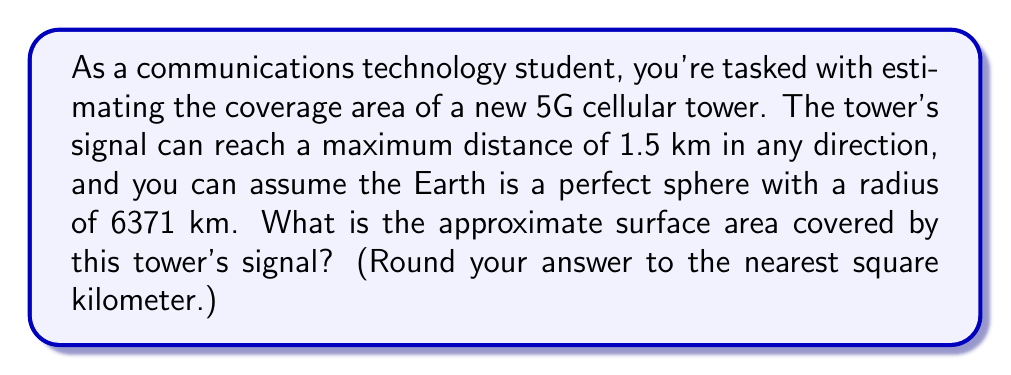Could you help me with this problem? To solve this problem, we'll use concepts from spherical geometry. Let's break it down step-by-step:

1) The coverage area of the cellular tower forms a spherical cap on the Earth's surface.

2) The radius of this spherical cap (r) is the maximum signal distance: 1.5 km.

3) We need to find the height (h) of this spherical cap:
   $$h = R - \sqrt{R^2 - r^2}$$
   where R is the Earth's radius (6371 km) and r is the signal radius (1.5 km).

4) Calculating h:
   $$h = 6371 - \sqrt{6371^2 - 1.5^2} \approx 0.000176 \text{ km}$$

5) The formula for the surface area of a spherical cap is:
   $$A = 2\pi Rh$$

6) Substituting our values:
   $$A = 2\pi(6371)(0.000176) \approx 7.0685 \text{ km}^2$$

7) Rounding to the nearest square kilometer:
   $$A \approx 7 \text{ km}^2$$

[asy]
import geometry;

size(200);
pair O = (0,0);
real R = 100;
real r = 23.5;
real h = R - sqrt(R^2 - r^2);

draw(circle(O, R));
draw((-r,sqrt(R^2-r^2))--O--(r,sqrt(R^2-r^2)), dashed);
draw((-r,sqrt(R^2-r^2))--(r,sqrt(R^2-r^2)));

label("R", (0,R/2), E);
label("r", (r/2,sqrt(R^2-r^2)), N);
label("h", (r,R-h/2), E);

dot(O);
[/asy]

This diagram illustrates the spherical cap formed by the tower's coverage area on the Earth's surface.
Answer: The approximate surface area covered by the cellular tower's signal is 7 km². 